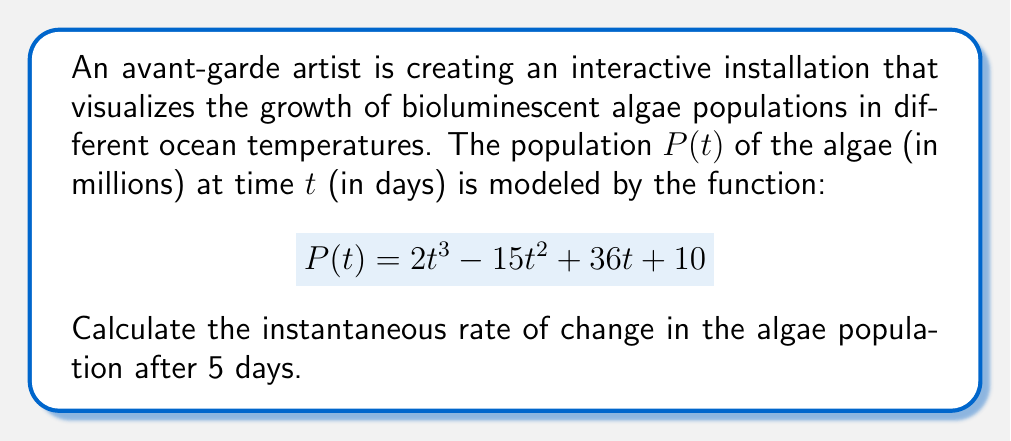Could you help me with this problem? To find the instantaneous rate of change, we need to calculate the derivative of the function $P(t)$ and evaluate it at $t=5$. Let's follow these steps:

1) First, let's find the derivative of $P(t)$:
   $$P(t) = 2t^3 - 15t^2 + 36t + 10$$
   $$P'(t) = 6t^2 - 30t + 36$$

2) Now, we need to evaluate $P'(t)$ at $t=5$:
   $$P'(5) = 6(5)^2 - 30(5) + 36$$
   
3) Let's calculate this step by step:
   $$P'(5) = 6(25) - 150 + 36$$
   $$P'(5) = 150 - 150 + 36$$
   $$P'(5) = 36$$

The result, 36, represents the instantaneous rate of change in millions of algae per day after 5 days.
Answer: $36$ million algae per day 